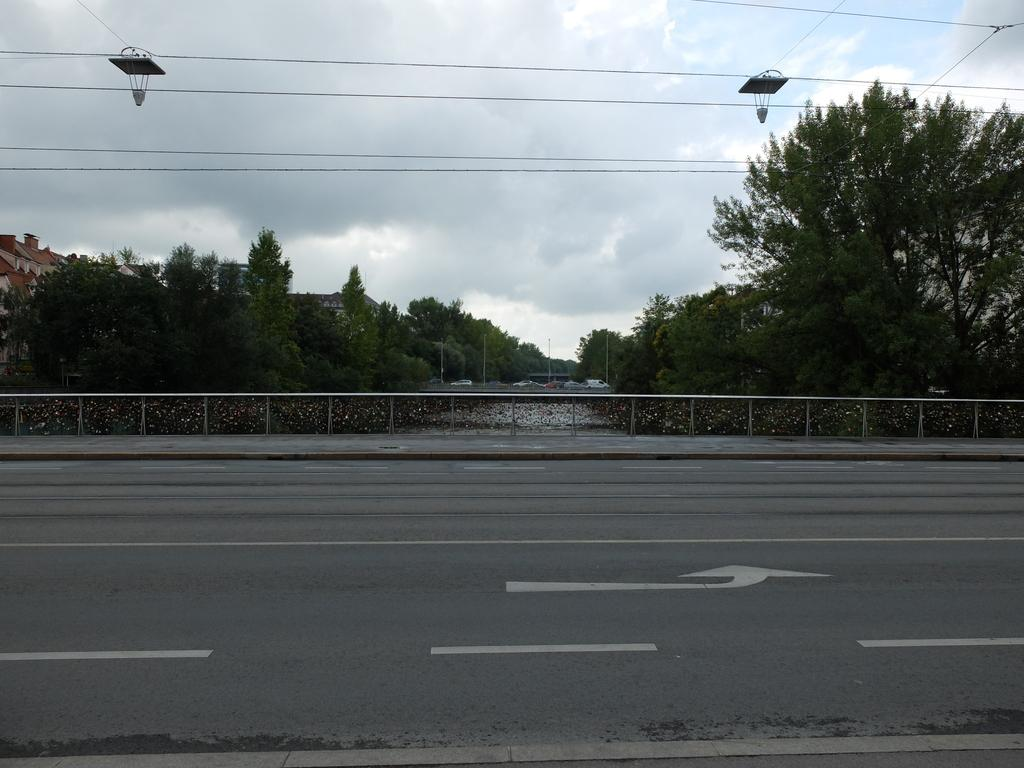What type of pathway can be seen in the image? There is a road in the image. What safety feature is present in the image? Railings are present in the image. What type of natural elements can be seen in the image? Trees are visible in the image. What type of man-made structures can be seen in the image? There are buildings in the image. What type of vertical structures are present in the image? Poles are present in the image. What type of transportation is visible in the image? Vehicles are visible in the image. What is the condition of the sky in the background of the image? The sky is cloudy in the background. What type of electrical infrastructure is present in the image? Wires are present in the image. What other objects can be seen in the image? There are other objects in the image. What type of button is being used to control the holiday in the image? There is no button or holiday present in the image. What type of class is being held in the image? There is no class or indication of a class being held in the image. 